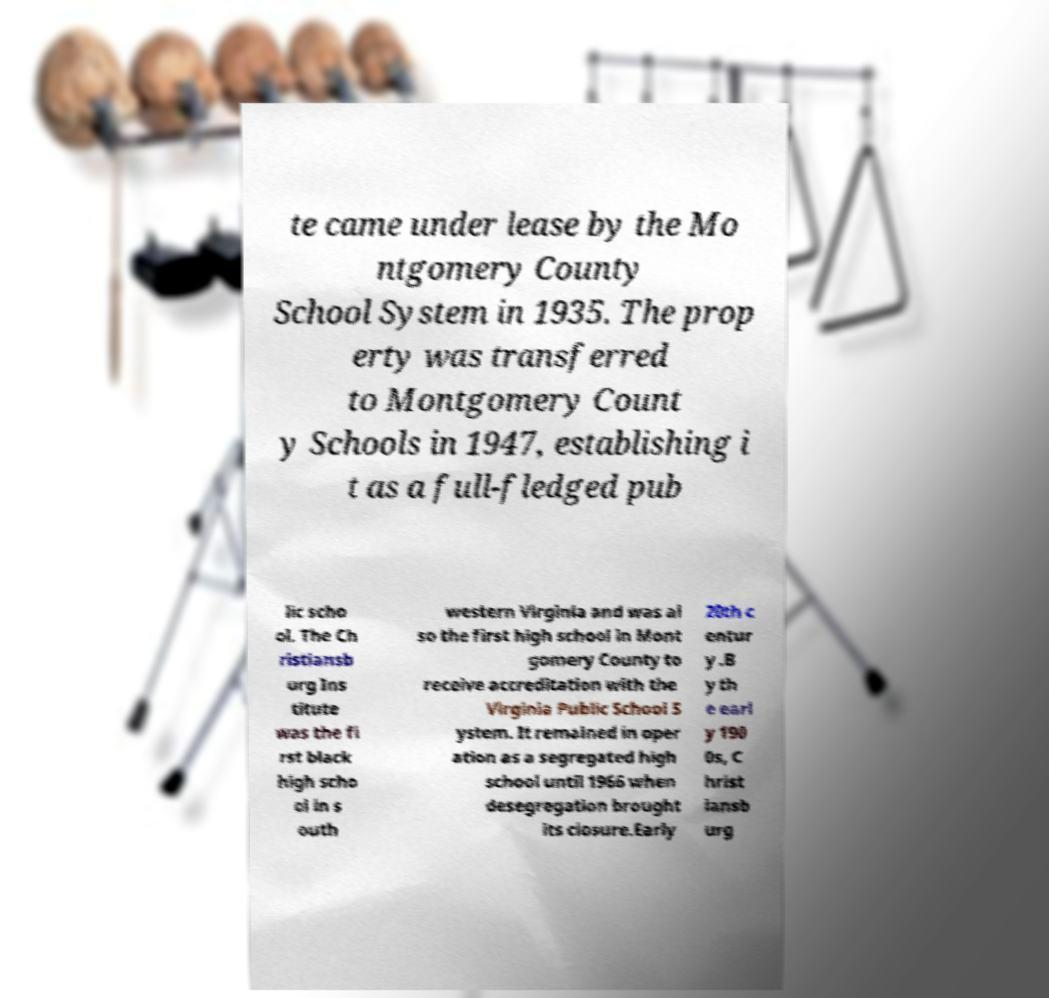I need the written content from this picture converted into text. Can you do that? te came under lease by the Mo ntgomery County School System in 1935. The prop erty was transferred to Montgomery Count y Schools in 1947, establishing i t as a full-fledged pub lic scho ol. The Ch ristiansb urg Ins titute was the fi rst black high scho ol in s outh western Virginia and was al so the first high school in Mont gomery County to receive accreditation with the Virginia Public School S ystem. It remained in oper ation as a segregated high school until 1966 when desegregation brought its closure.Early 20th c entur y .B y th e earl y 190 0s, C hrist iansb urg 